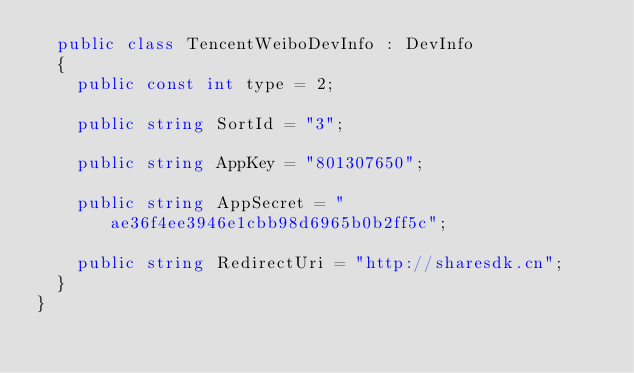<code> <loc_0><loc_0><loc_500><loc_500><_C#_>	public class TencentWeiboDevInfo : DevInfo
	{
		public const int type = 2;

		public string SortId = "3";

		public string AppKey = "801307650";

		public string AppSecret = "ae36f4ee3946e1cbb98d6965b0b2ff5c";

		public string RedirectUri = "http://sharesdk.cn";
	}
}
</code> 